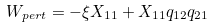Convert formula to latex. <formula><loc_0><loc_0><loc_500><loc_500>W _ { p e r t } = - \xi X _ { 1 1 } + X _ { 1 1 } q _ { 1 2 } q _ { 2 1 }</formula> 